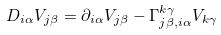Convert formula to latex. <formula><loc_0><loc_0><loc_500><loc_500>D _ { i \alpha } V _ { j \beta } = \partial _ { i \alpha } V _ { j \beta } - \Gamma ^ { k \gamma } _ { j \beta , i \alpha } V _ { k \gamma }</formula> 